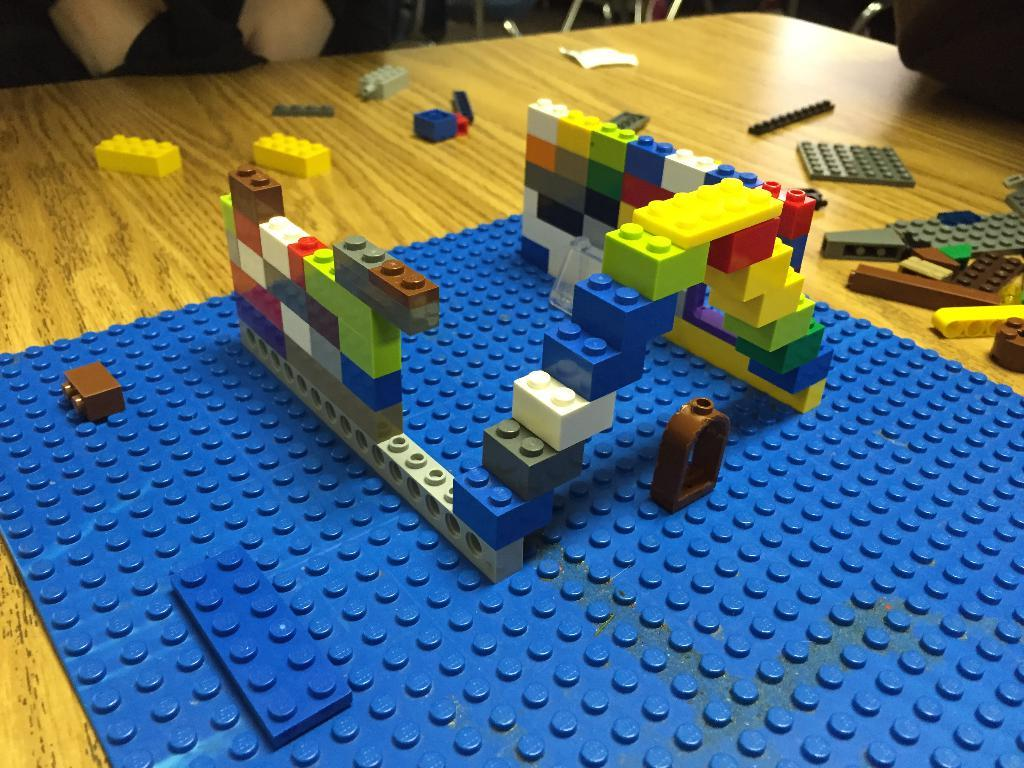What type of items can be seen in the image? There are toys and objects in the image. Can you describe the colors of some of the objects? Some of the objects are black in color, and some are brown in color. What type of noise can be heard coming from the basket in the image? There is no basket present in the image, so it's not possible to determine what, if any, noise might be heard. 